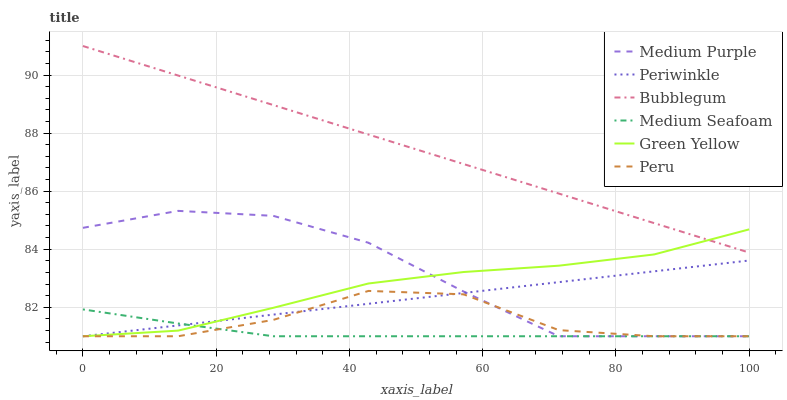Does Medium Seafoam have the minimum area under the curve?
Answer yes or no. Yes. Does Bubblegum have the maximum area under the curve?
Answer yes or no. Yes. Does Medium Purple have the minimum area under the curve?
Answer yes or no. No. Does Medium Purple have the maximum area under the curve?
Answer yes or no. No. Is Periwinkle the smoothest?
Answer yes or no. Yes. Is Peru the roughest?
Answer yes or no. Yes. Is Medium Purple the smoothest?
Answer yes or no. No. Is Medium Purple the roughest?
Answer yes or no. No. Does Medium Purple have the lowest value?
Answer yes or no. Yes. Does Bubblegum have the highest value?
Answer yes or no. Yes. Does Medium Purple have the highest value?
Answer yes or no. No. Is Periwinkle less than Bubblegum?
Answer yes or no. Yes. Is Bubblegum greater than Medium Purple?
Answer yes or no. Yes. Does Medium Purple intersect Medium Seafoam?
Answer yes or no. Yes. Is Medium Purple less than Medium Seafoam?
Answer yes or no. No. Is Medium Purple greater than Medium Seafoam?
Answer yes or no. No. Does Periwinkle intersect Bubblegum?
Answer yes or no. No. 